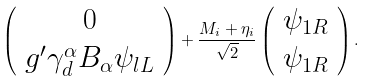<formula> <loc_0><loc_0><loc_500><loc_500>\left ( \begin{array} { c } 0 \\ g ^ { \prime } \gamma _ { d } ^ { \alpha } B _ { \alpha } \psi _ { l L } \end{array} \right ) + \frac { M _ { i } + \eta _ { i } } { \sqrt { 2 } } \left ( \begin{array} { c } \psi _ { 1 R } \\ \psi _ { 1 R } \end{array} \right ) .</formula> 